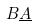Convert formula to latex. <formula><loc_0><loc_0><loc_500><loc_500>B \underline { A }</formula> 